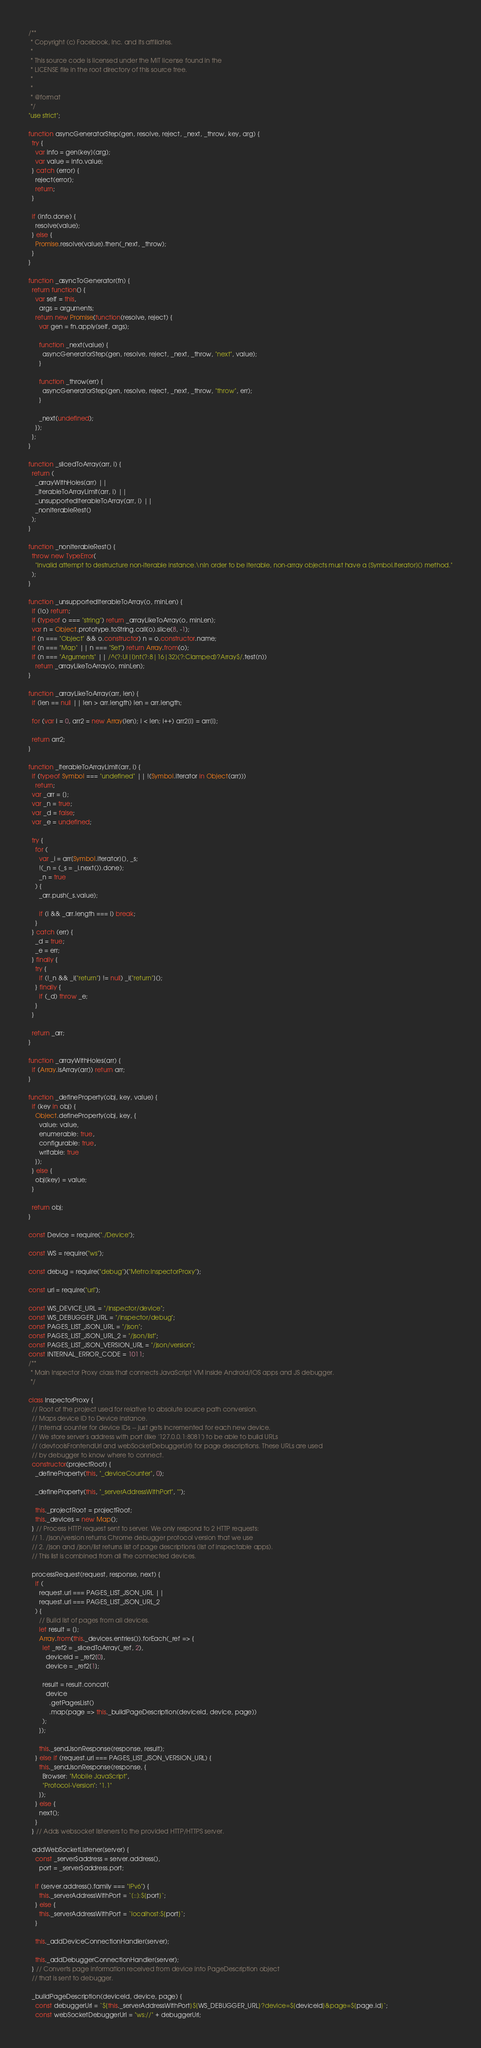<code> <loc_0><loc_0><loc_500><loc_500><_JavaScript_>/**
 * Copyright (c) Facebook, Inc. and its affiliates.
 *
 * This source code is licensed under the MIT license found in the
 * LICENSE file in the root directory of this source tree.
 *
 *
 * @format
 */
"use strict";

function asyncGeneratorStep(gen, resolve, reject, _next, _throw, key, arg) {
  try {
    var info = gen[key](arg);
    var value = info.value;
  } catch (error) {
    reject(error);
    return;
  }

  if (info.done) {
    resolve(value);
  } else {
    Promise.resolve(value).then(_next, _throw);
  }
}

function _asyncToGenerator(fn) {
  return function() {
    var self = this,
      args = arguments;
    return new Promise(function(resolve, reject) {
      var gen = fn.apply(self, args);

      function _next(value) {
        asyncGeneratorStep(gen, resolve, reject, _next, _throw, "next", value);
      }

      function _throw(err) {
        asyncGeneratorStep(gen, resolve, reject, _next, _throw, "throw", err);
      }

      _next(undefined);
    });
  };
}

function _slicedToArray(arr, i) {
  return (
    _arrayWithHoles(arr) ||
    _iterableToArrayLimit(arr, i) ||
    _unsupportedIterableToArray(arr, i) ||
    _nonIterableRest()
  );
}

function _nonIterableRest() {
  throw new TypeError(
    "Invalid attempt to destructure non-iterable instance.\nIn order to be iterable, non-array objects must have a [Symbol.iterator]() method."
  );
}

function _unsupportedIterableToArray(o, minLen) {
  if (!o) return;
  if (typeof o === "string") return _arrayLikeToArray(o, minLen);
  var n = Object.prototype.toString.call(o).slice(8, -1);
  if (n === "Object" && o.constructor) n = o.constructor.name;
  if (n === "Map" || n === "Set") return Array.from(o);
  if (n === "Arguments" || /^(?:Ui|I)nt(?:8|16|32)(?:Clamped)?Array$/.test(n))
    return _arrayLikeToArray(o, minLen);
}

function _arrayLikeToArray(arr, len) {
  if (len == null || len > arr.length) len = arr.length;

  for (var i = 0, arr2 = new Array(len); i < len; i++) arr2[i] = arr[i];

  return arr2;
}

function _iterableToArrayLimit(arr, i) {
  if (typeof Symbol === "undefined" || !(Symbol.iterator in Object(arr)))
    return;
  var _arr = [];
  var _n = true;
  var _d = false;
  var _e = undefined;

  try {
    for (
      var _i = arr[Symbol.iterator](), _s;
      !(_n = (_s = _i.next()).done);
      _n = true
    ) {
      _arr.push(_s.value);

      if (i && _arr.length === i) break;
    }
  } catch (err) {
    _d = true;
    _e = err;
  } finally {
    try {
      if (!_n && _i["return"] != null) _i["return"]();
    } finally {
      if (_d) throw _e;
    }
  }

  return _arr;
}

function _arrayWithHoles(arr) {
  if (Array.isArray(arr)) return arr;
}

function _defineProperty(obj, key, value) {
  if (key in obj) {
    Object.defineProperty(obj, key, {
      value: value,
      enumerable: true,
      configurable: true,
      writable: true
    });
  } else {
    obj[key] = value;
  }

  return obj;
}

const Device = require("./Device");

const WS = require("ws");

const debug = require("debug")("Metro:InspectorProxy");

const url = require("url");

const WS_DEVICE_URL = "/inspector/device";
const WS_DEBUGGER_URL = "/inspector/debug";
const PAGES_LIST_JSON_URL = "/json";
const PAGES_LIST_JSON_URL_2 = "/json/list";
const PAGES_LIST_JSON_VERSION_URL = "/json/version";
const INTERNAL_ERROR_CODE = 1011;
/**
 * Main Inspector Proxy class that connects JavaScript VM inside Android/iOS apps and JS debugger.
 */

class InspectorProxy {
  // Root of the project used for relative to absolute source path conversion.
  // Maps device ID to Device instance.
  // Internal counter for device IDs -- just gets incremented for each new device.
  // We store server's address with port (like '127.0.0.1:8081') to be able to build URLs
  // (devtoolsFrontendUrl and webSocketDebuggerUrl) for page descriptions. These URLs are used
  // by debugger to know where to connect.
  constructor(projectRoot) {
    _defineProperty(this, "_deviceCounter", 0);

    _defineProperty(this, "_serverAddressWithPort", "");

    this._projectRoot = projectRoot;
    this._devices = new Map();
  } // Process HTTP request sent to server. We only respond to 2 HTTP requests:
  // 1. /json/version returns Chrome debugger protocol version that we use
  // 2. /json and /json/list returns list of page descriptions (list of inspectable apps).
  // This list is combined from all the connected devices.

  processRequest(request, response, next) {
    if (
      request.url === PAGES_LIST_JSON_URL ||
      request.url === PAGES_LIST_JSON_URL_2
    ) {
      // Build list of pages from all devices.
      let result = [];
      Array.from(this._devices.entries()).forEach(_ref => {
        let _ref2 = _slicedToArray(_ref, 2),
          deviceId = _ref2[0],
          device = _ref2[1];

        result = result.concat(
          device
            .getPagesList()
            .map(page => this._buildPageDescription(deviceId, device, page))
        );
      });

      this._sendJsonResponse(response, result);
    } else if (request.url === PAGES_LIST_JSON_VERSION_URL) {
      this._sendJsonResponse(response, {
        Browser: "Mobile JavaScript",
        "Protocol-Version": "1.1"
      });
    } else {
      next();
    }
  } // Adds websocket listeners to the provided HTTP/HTTPS server.

  addWebSocketListener(server) {
    const _server$address = server.address(),
      port = _server$address.port;

    if (server.address().family === "IPv6") {
      this._serverAddressWithPort = `[::]:${port}`;
    } else {
      this._serverAddressWithPort = `localhost:${port}`;
    }

    this._addDeviceConnectionHandler(server);

    this._addDebuggerConnectionHandler(server);
  } // Converts page information received from device into PageDescription object
  // that is sent to debugger.

  _buildPageDescription(deviceId, device, page) {
    const debuggerUrl = `${this._serverAddressWithPort}${WS_DEBUGGER_URL}?device=${deviceId}&page=${page.id}`;
    const webSocketDebuggerUrl = "ws://" + debuggerUrl;</code> 